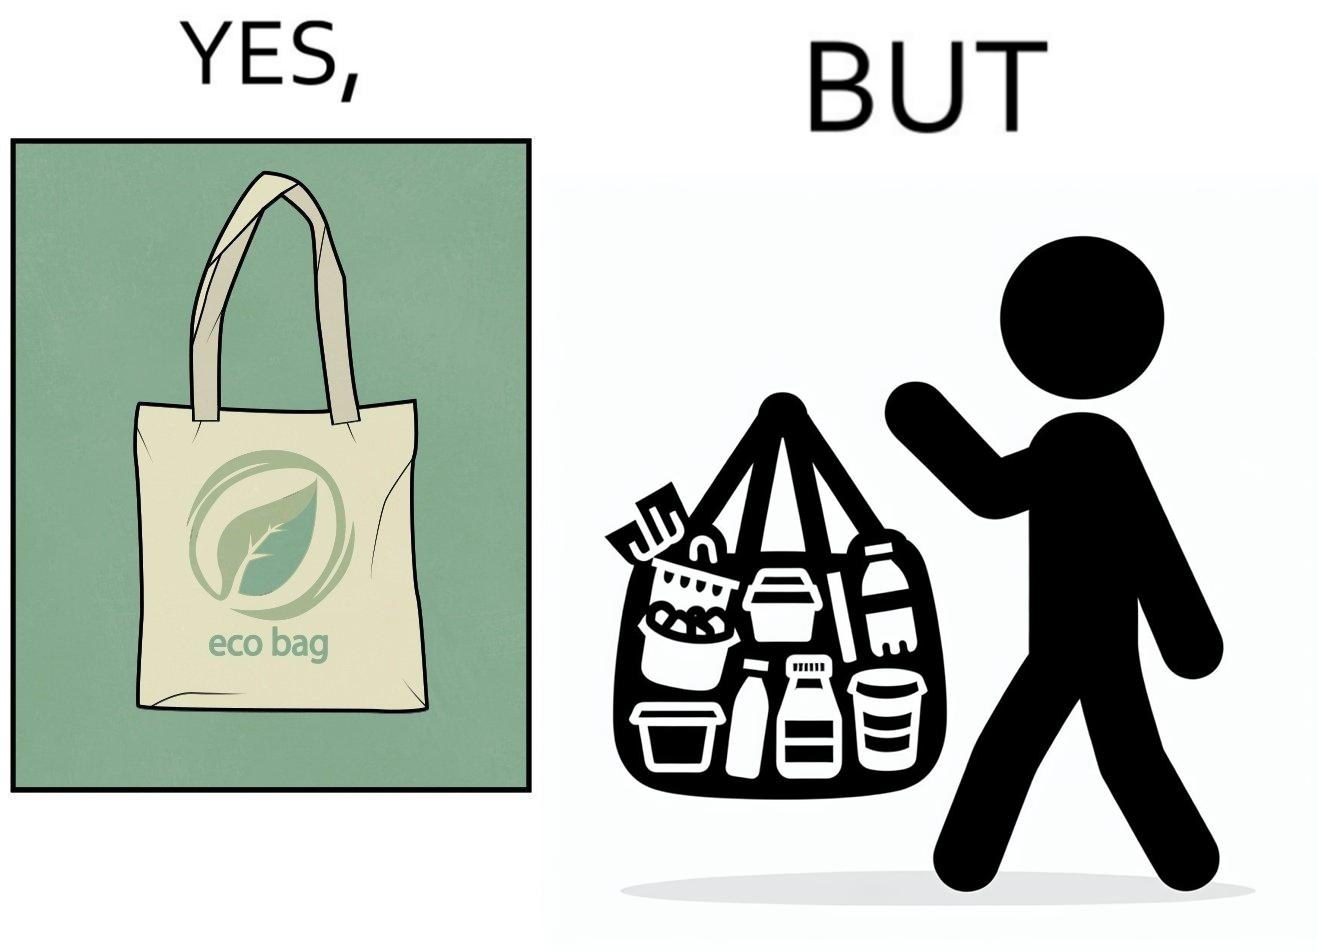What is shown in the left half versus the right half of this image? In the left part of the image: a bag with text "eco-bag" on it, probably made up of some eco-friendly materials like cotton or jute In the right part of the image: a person carrying different products inside plastic containers or plastic wrapping in a carry bag 